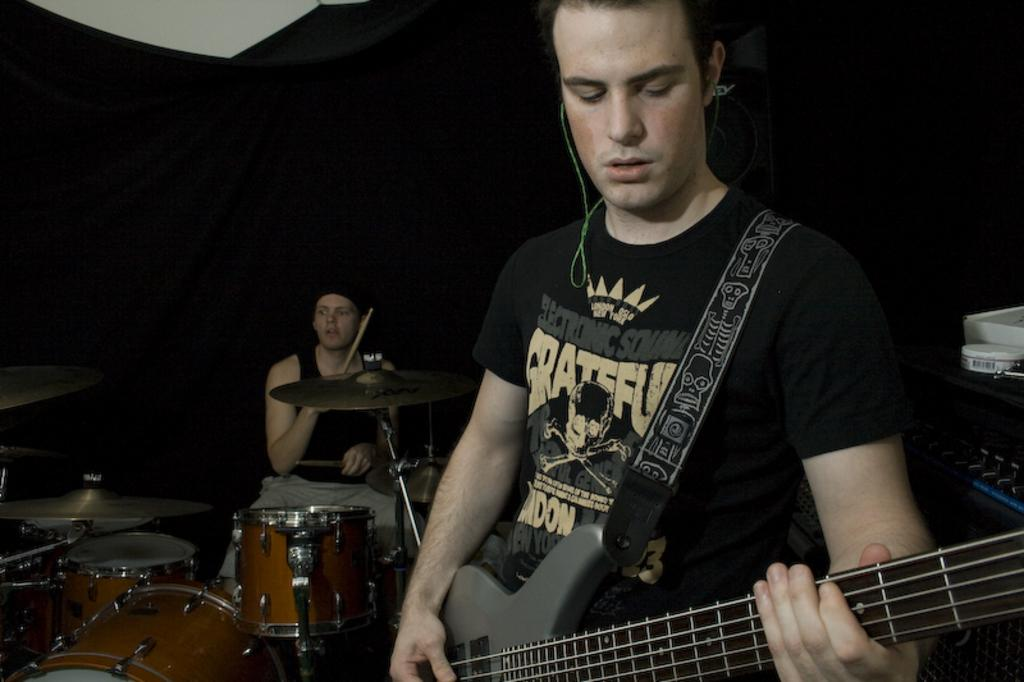What is the main activity of the person standing in the image? The person standing in the image is playing the guitar. What is the main activity of the person sitting in the image? The sitting person is playing musical drums. How many people are involved in the musical activity in the image? There are two people involved in the musical activity in the image. What type of paint is being used by the person playing the guitar in the image? There is no paint or painting activity present in the image; the person is playing the guitar. 